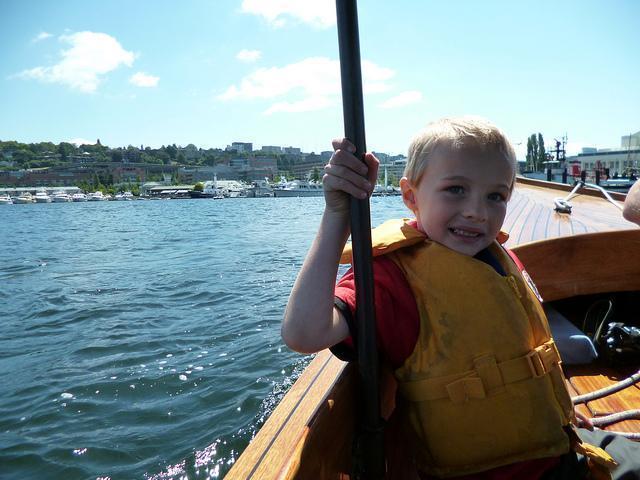How many boats can be seen?
Give a very brief answer. 2. 